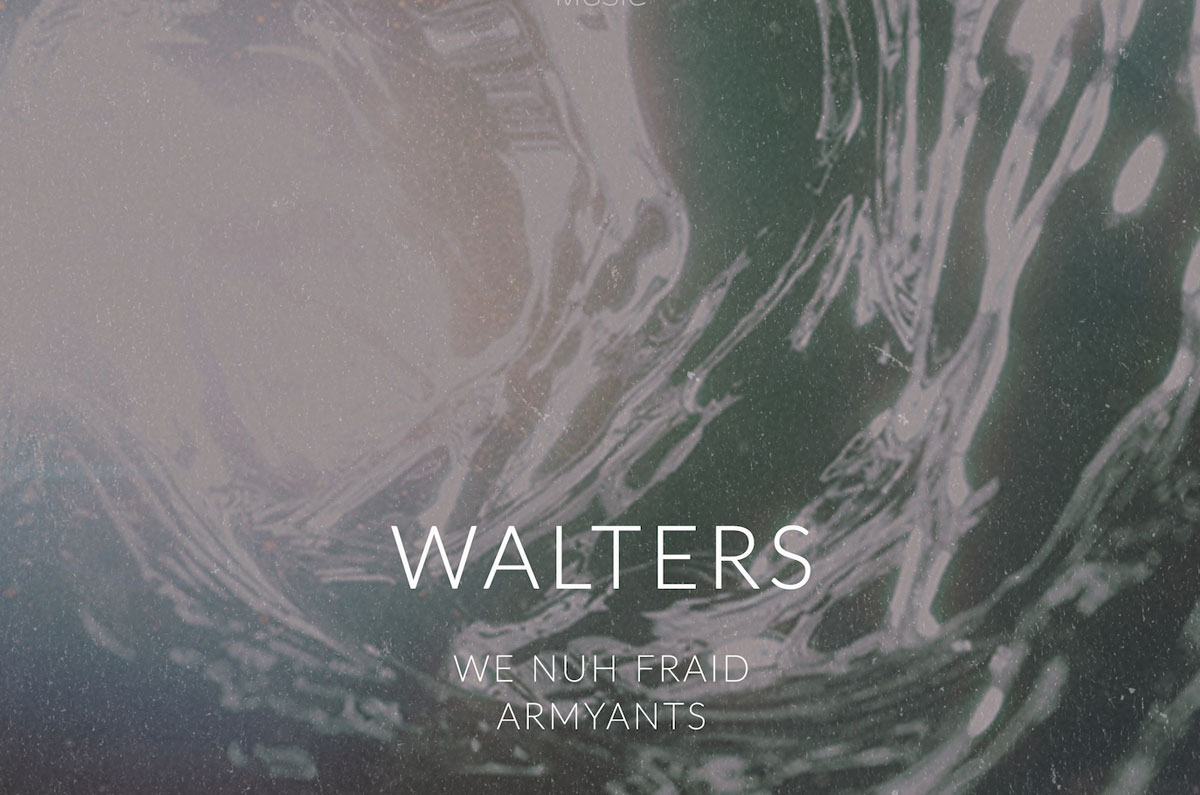What emotions or feelings does the image evoke through its design elements? The image evokes a sense of intrigue and contemplation through its combination of typographic hierarchy and a swirling, marbled background. The dominant text 'WALTERS' suggests importance and solidity, while the fluid and abstract nature of the background adds a layer of mystery and depth. This juxtaposition between stable text and dynamic background can evoke feelings of curiosity and an urge to uncover the story behind the image. Can you explain how the color scheme contributes to the overall aesthetic of the image? The color scheme of the image plays a crucial role in setting its mood and enhancing its aesthetic appeal. The soft, pastel tones of the marbled background contrast gently with the white text, creating a calming yet intriguing visual effect. The use of subdued colors avoids overwhelming the viewer, allowing the typographic elements to stand out prominently. This balanced color palette contributes to a harmonious and sophisticated look, inviting viewers to engage with the image without distraction. Imagine a scenario where this image is the cover of a music album. What genre of music do you think it could represent? Given its abstract and sophisticated design, this image could very well represent a genre such as ambient music, alternative rock, or even experimental electronic music. The swirling marbled background suggests a fluid and dynamic experience akin to the layering and texturing typical in these genres. The bold text 'WALTERS,' combined with phrases like 'WE NUH FRAID' and 'ARMYANTS,' hints at themes of resilience and distinctiveness, which align with the often introspective and innovative nature of these musical styles. 